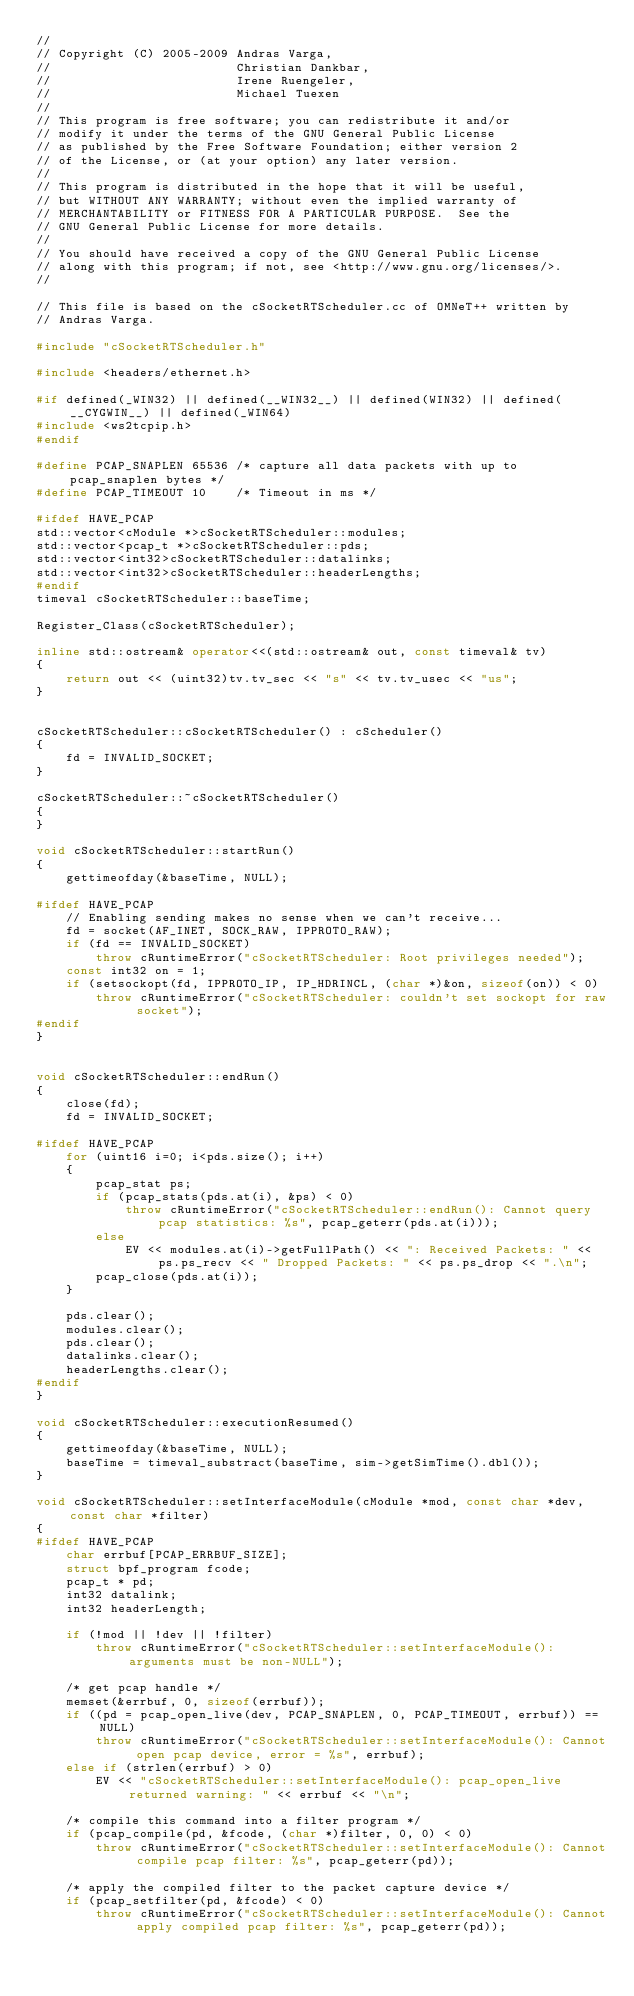<code> <loc_0><loc_0><loc_500><loc_500><_C++_>//
// Copyright (C) 2005-2009 Andras Varga,
//                         Christian Dankbar,
//                         Irene Ruengeler,
//                         Michael Tuexen
//
// This program is free software; you can redistribute it and/or
// modify it under the terms of the GNU General Public License
// as published by the Free Software Foundation; either version 2
// of the License, or (at your option) any later version.
//
// This program is distributed in the hope that it will be useful,
// but WITHOUT ANY WARRANTY; without even the implied warranty of
// MERCHANTABILITY or FITNESS FOR A PARTICULAR PURPOSE.  See the
// GNU General Public License for more details.
//
// You should have received a copy of the GNU General Public License
// along with this program; if not, see <http://www.gnu.org/licenses/>.
//

// This file is based on the cSocketRTScheduler.cc of OMNeT++ written by
// Andras Varga.

#include "cSocketRTScheduler.h"

#include <headers/ethernet.h>

#if defined(_WIN32) || defined(__WIN32__) || defined(WIN32) || defined(__CYGWIN__) || defined(_WIN64)
#include <ws2tcpip.h>
#endif

#define PCAP_SNAPLEN 65536 /* capture all data packets with up to pcap_snaplen bytes */
#define PCAP_TIMEOUT 10    /* Timeout in ms */

#ifdef HAVE_PCAP
std::vector<cModule *>cSocketRTScheduler::modules;
std::vector<pcap_t *>cSocketRTScheduler::pds;
std::vector<int32>cSocketRTScheduler::datalinks;
std::vector<int32>cSocketRTScheduler::headerLengths;
#endif
timeval cSocketRTScheduler::baseTime;

Register_Class(cSocketRTScheduler);

inline std::ostream& operator<<(std::ostream& out, const timeval& tv)
{
    return out << (uint32)tv.tv_sec << "s" << tv.tv_usec << "us";
}


cSocketRTScheduler::cSocketRTScheduler() : cScheduler()
{
    fd = INVALID_SOCKET;
}

cSocketRTScheduler::~cSocketRTScheduler()
{
}

void cSocketRTScheduler::startRun()
{
    gettimeofday(&baseTime, NULL);

#ifdef HAVE_PCAP
    // Enabling sending makes no sense when we can't receive...
    fd = socket(AF_INET, SOCK_RAW, IPPROTO_RAW);
    if (fd == INVALID_SOCKET)
        throw cRuntimeError("cSocketRTScheduler: Root privileges needed");
    const int32 on = 1;
    if (setsockopt(fd, IPPROTO_IP, IP_HDRINCL, (char *)&on, sizeof(on)) < 0)
        throw cRuntimeError("cSocketRTScheduler: couldn't set sockopt for raw socket");
#endif
}


void cSocketRTScheduler::endRun()
{
    close(fd);
    fd = INVALID_SOCKET;

#ifdef HAVE_PCAP
    for (uint16 i=0; i<pds.size(); i++)
    {
        pcap_stat ps;
        if (pcap_stats(pds.at(i), &ps) < 0)
            throw cRuntimeError("cSocketRTScheduler::endRun(): Cannot query pcap statistics: %s", pcap_geterr(pds.at(i)));
        else
            EV << modules.at(i)->getFullPath() << ": Received Packets: " << ps.ps_recv << " Dropped Packets: " << ps.ps_drop << ".\n";
        pcap_close(pds.at(i));
    }

    pds.clear();
    modules.clear();
    pds.clear();
    datalinks.clear();
    headerLengths.clear();
#endif
}

void cSocketRTScheduler::executionResumed()
{
    gettimeofday(&baseTime, NULL);
    baseTime = timeval_substract(baseTime, sim->getSimTime().dbl());
}

void cSocketRTScheduler::setInterfaceModule(cModule *mod, const char *dev, const char *filter)
{
#ifdef HAVE_PCAP
    char errbuf[PCAP_ERRBUF_SIZE];
    struct bpf_program fcode;
    pcap_t * pd;
    int32 datalink;
    int32 headerLength;

    if (!mod || !dev || !filter)
        throw cRuntimeError("cSocketRTScheduler::setInterfaceModule(): arguments must be non-NULL");

    /* get pcap handle */
    memset(&errbuf, 0, sizeof(errbuf));
    if ((pd = pcap_open_live(dev, PCAP_SNAPLEN, 0, PCAP_TIMEOUT, errbuf)) == NULL)
        throw cRuntimeError("cSocketRTScheduler::setInterfaceModule(): Cannot open pcap device, error = %s", errbuf);
    else if (strlen(errbuf) > 0)
        EV << "cSocketRTScheduler::setInterfaceModule(): pcap_open_live returned warning: " << errbuf << "\n";

    /* compile this command into a filter program */
    if (pcap_compile(pd, &fcode, (char *)filter, 0, 0) < 0)
        throw cRuntimeError("cSocketRTScheduler::setInterfaceModule(): Cannot compile pcap filter: %s", pcap_geterr(pd));

    /* apply the compiled filter to the packet capture device */
    if (pcap_setfilter(pd, &fcode) < 0)
        throw cRuntimeError("cSocketRTScheduler::setInterfaceModule(): Cannot apply compiled pcap filter: %s", pcap_geterr(pd));
</code> 